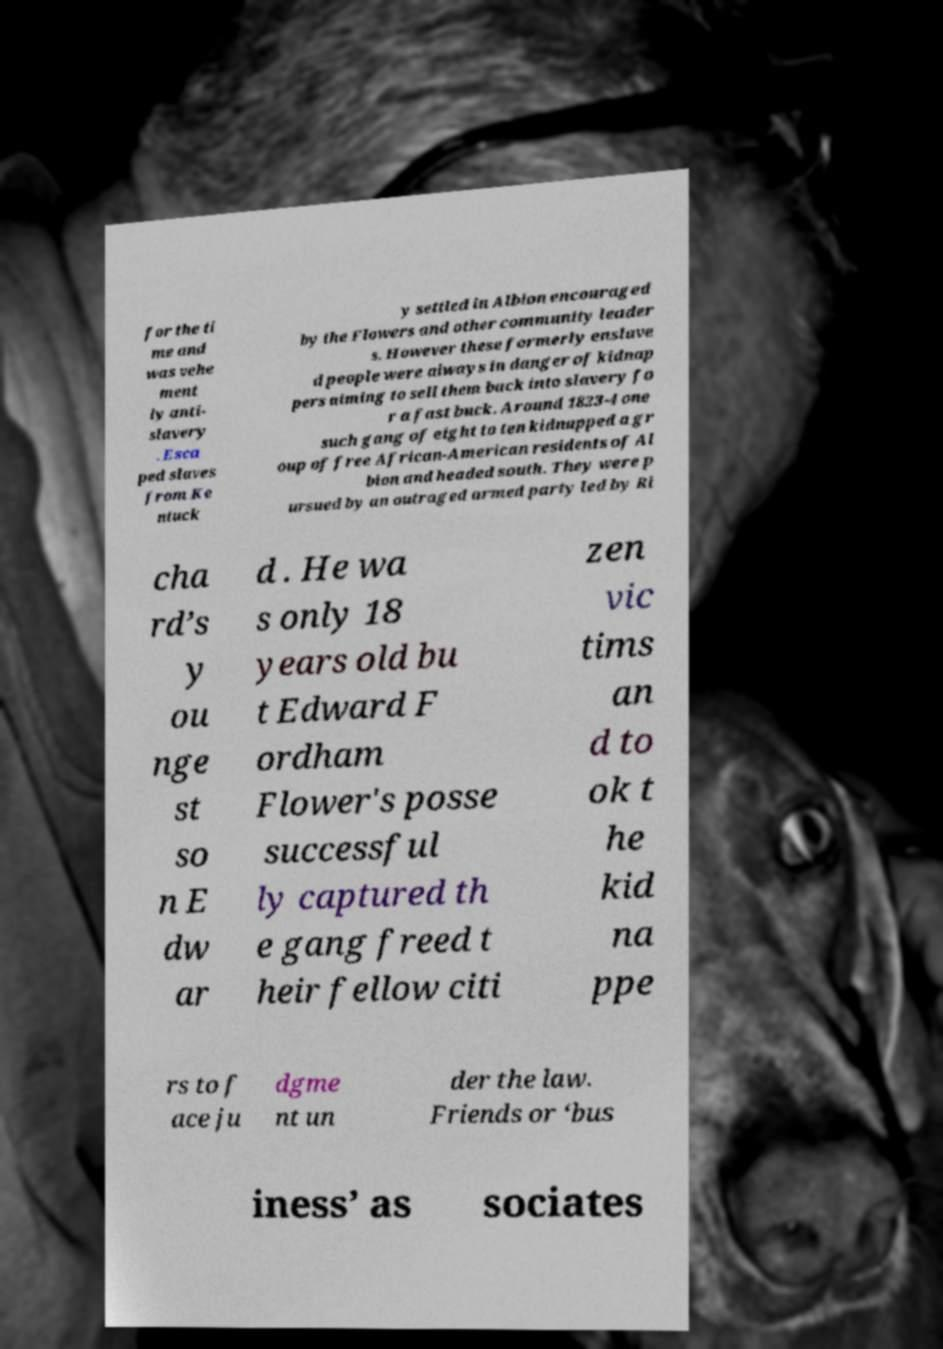Can you read and provide the text displayed in the image?This photo seems to have some interesting text. Can you extract and type it out for me? for the ti me and was vehe ment ly anti- slavery . Esca ped slaves from Ke ntuck y settled in Albion encouraged by the Flowers and other community leader s. However these formerly enslave d people were always in danger of kidnap pers aiming to sell them back into slavery fo r a fast buck. Around 1823-4 one such gang of eight to ten kidnapped a gr oup of free African-American residents of Al bion and headed south. They were p ursued by an outraged armed party led by Ri cha rd’s y ou nge st so n E dw ar d . He wa s only 18 years old bu t Edward F ordham Flower's posse successful ly captured th e gang freed t heir fellow citi zen vic tims an d to ok t he kid na ppe rs to f ace ju dgme nt un der the law. Friends or ‘bus iness’ as sociates 